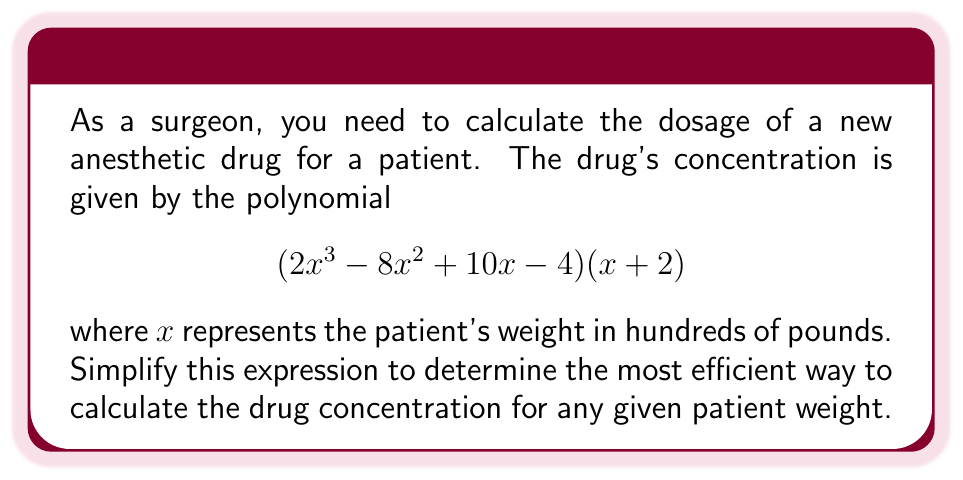Teach me how to tackle this problem. Let's simplify the expression by multiplying the two factors:

1) First, distribute $(x + 2)$ to each term in the first factor:

   $$(2x^3 - 8x^2 + 10x - 4)(x + 2) = 2x^3(x + 2) - 8x^2(x + 2) + 10x(x + 2) - 4(x + 2)$$

2) Now, let's multiply each term:

   $$= (2x^4 + 4x^3) - (8x^3 + 16x^2) + (10x^2 + 20x) - (4x + 8)$$

3) Rearrange the terms in descending order of exponents:

   $$= 2x^4 + 4x^3 - 8x^3 - 16x^2 + 10x^2 + 20x - 4x - 8$$

4) Combine like terms:

   $$= 2x^4 + (4 - 8)x^3 + (-16 + 10)x^2 + (20 - 4)x - 8$$

5) Simplify:

   $$= 2x^4 - 4x^3 - 6x^2 + 16x - 8$$

This simplified polynomial represents the most efficient way to calculate the drug concentration based on the patient's weight.
Answer: $$2x^4 - 4x^3 - 6x^2 + 16x - 8$$ 